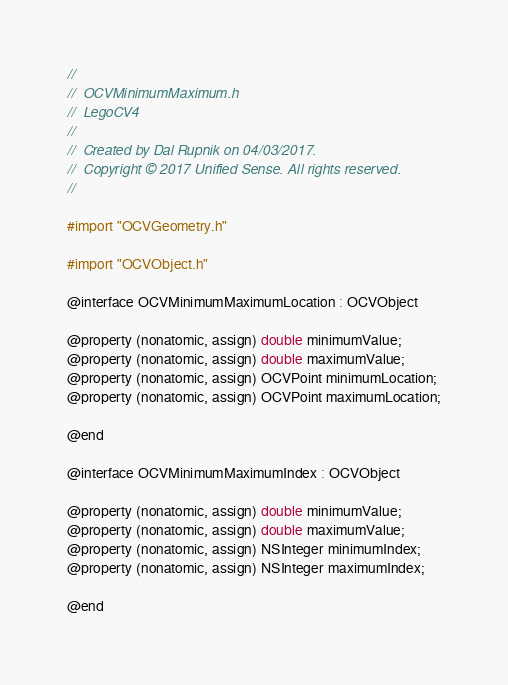<code> <loc_0><loc_0><loc_500><loc_500><_C_>//
//  OCVMinimumMaximum.h
//  LegoCV4
//
//  Created by Dal Rupnik on 04/03/2017.
//  Copyright © 2017 Unified Sense. All rights reserved.
//

#import "OCVGeometry.h"

#import "OCVObject.h"

@interface OCVMinimumMaximumLocation : OCVObject

@property (nonatomic, assign) double minimumValue;
@property (nonatomic, assign) double maximumValue;
@property (nonatomic, assign) OCVPoint minimumLocation;
@property (nonatomic, assign) OCVPoint maximumLocation;

@end

@interface OCVMinimumMaximumIndex : OCVObject

@property (nonatomic, assign) double minimumValue;
@property (nonatomic, assign) double maximumValue;
@property (nonatomic, assign) NSInteger minimumIndex;
@property (nonatomic, assign) NSInteger maximumIndex;

@end
</code> 